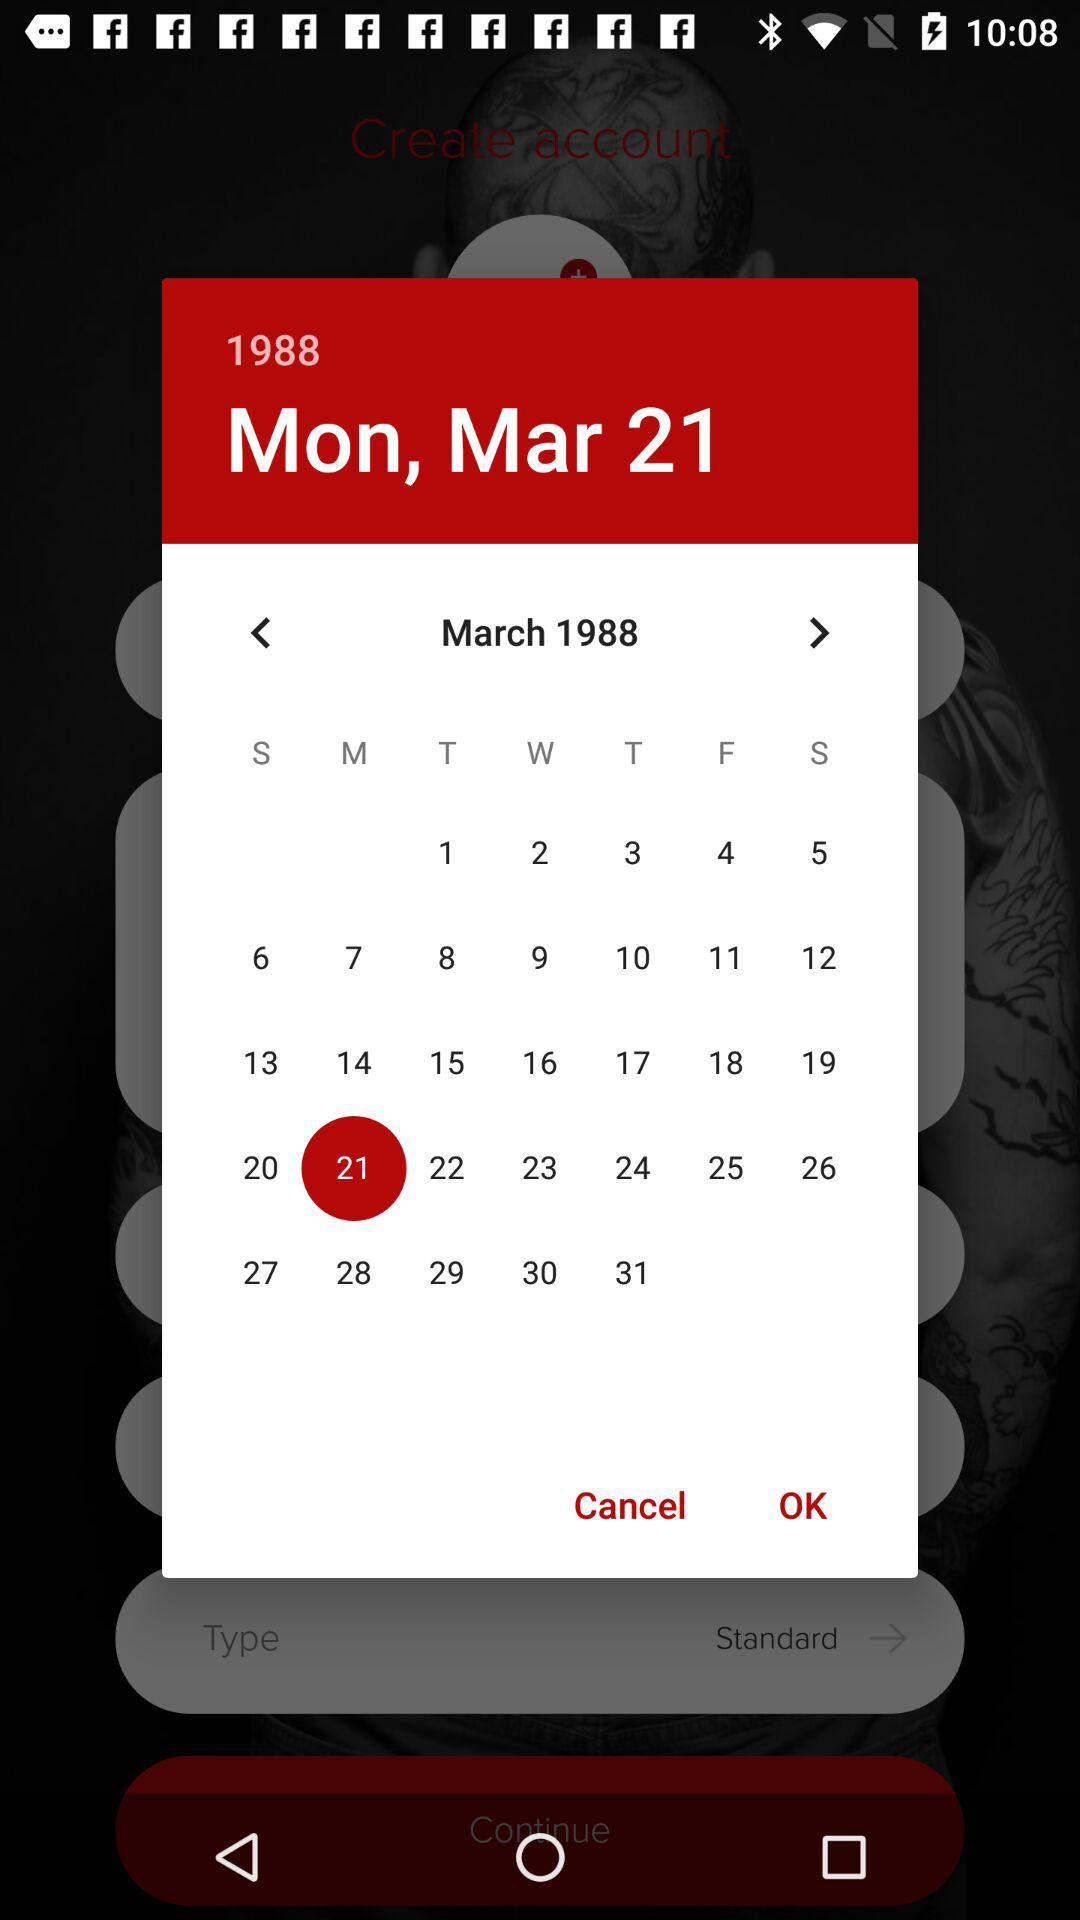What is the mentioned date? The date is Monday, March 21, 1988. 